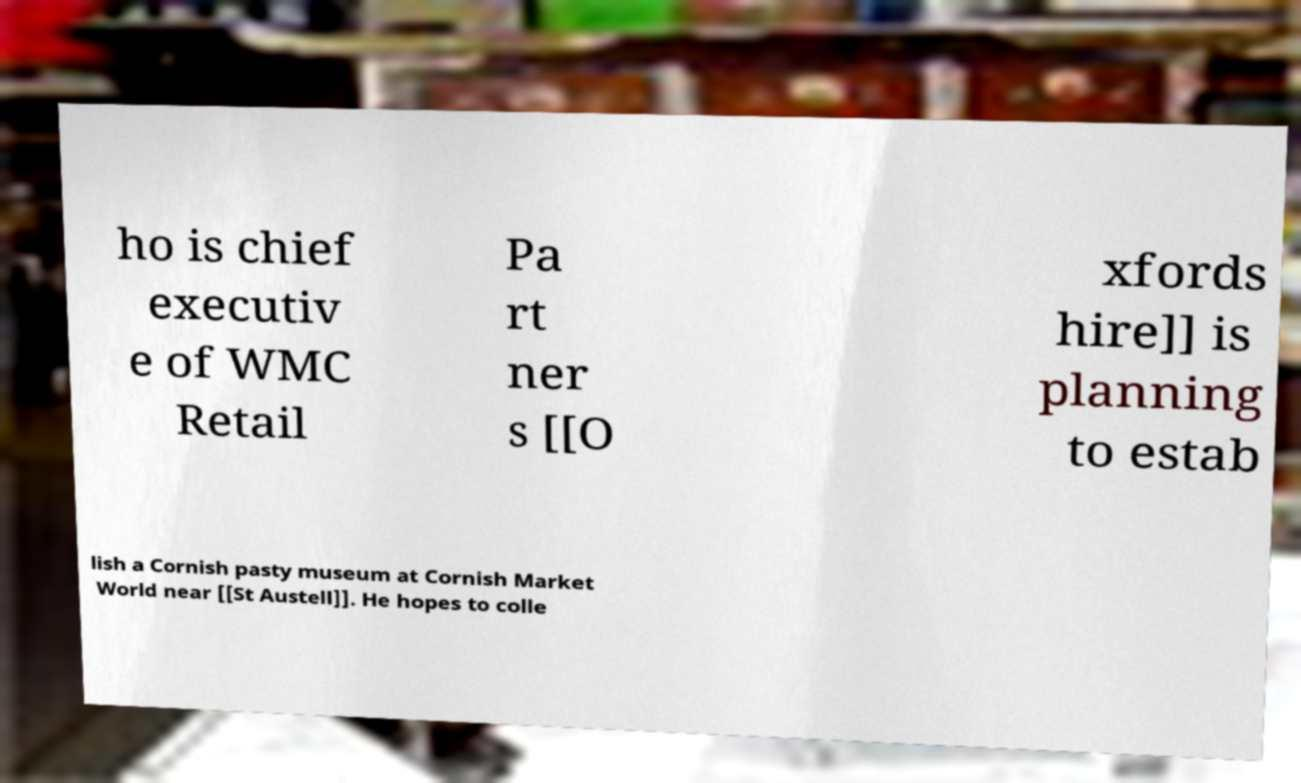Please identify and transcribe the text found in this image. ho is chief executiv e of WMC Retail Pa rt ner s [[O xfords hire]] is planning to estab lish a Cornish pasty museum at Cornish Market World near [[St Austell]]. He hopes to colle 